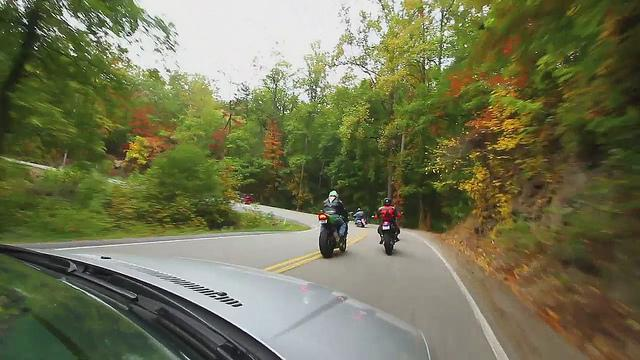How many motorcycles are on the highway apparently ahead of the vehicle driving? three 